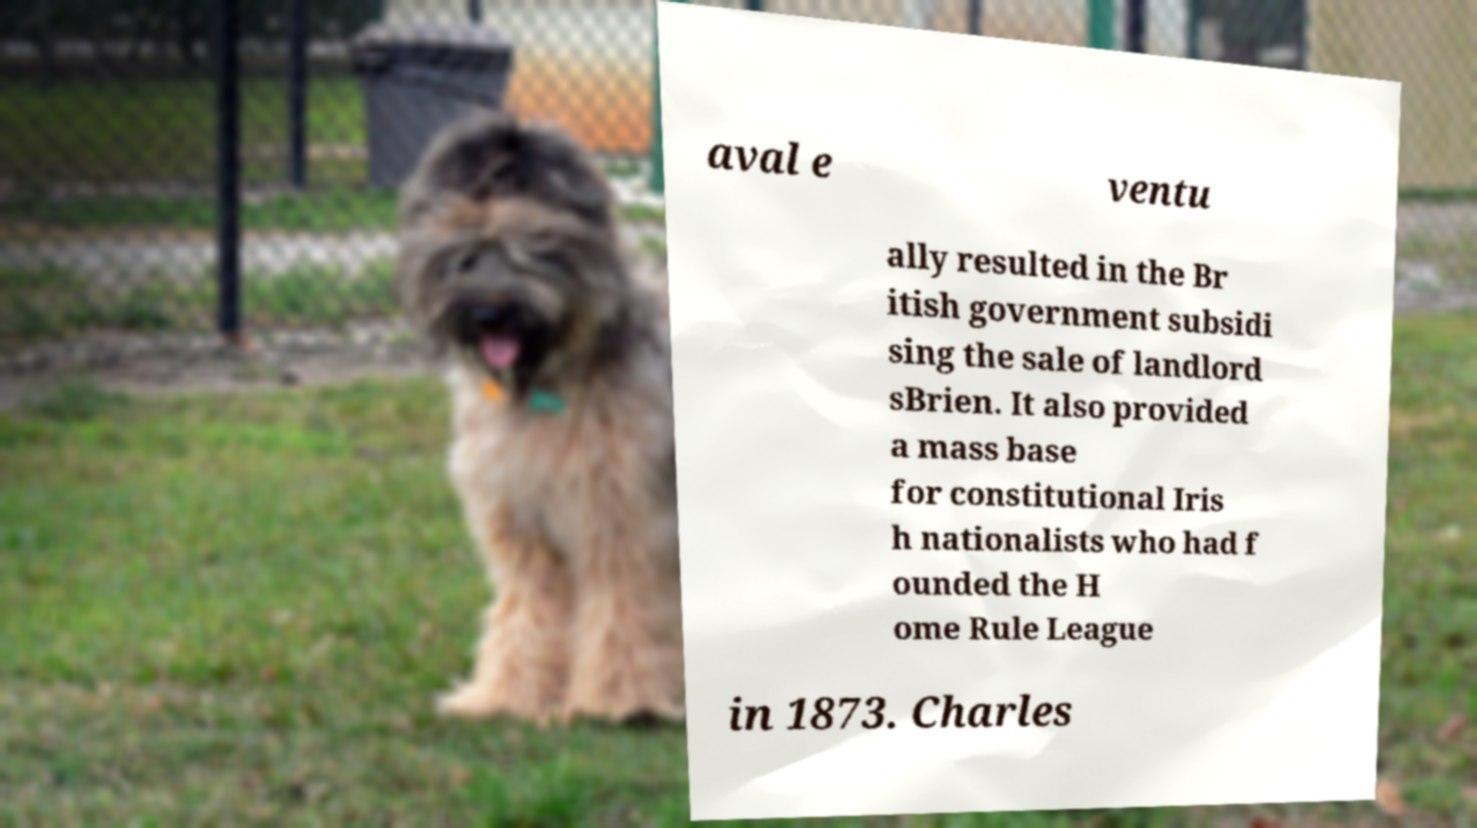I need the written content from this picture converted into text. Can you do that? aval e ventu ally resulted in the Br itish government subsidi sing the sale of landlord sBrien. It also provided a mass base for constitutional Iris h nationalists who had f ounded the H ome Rule League in 1873. Charles 